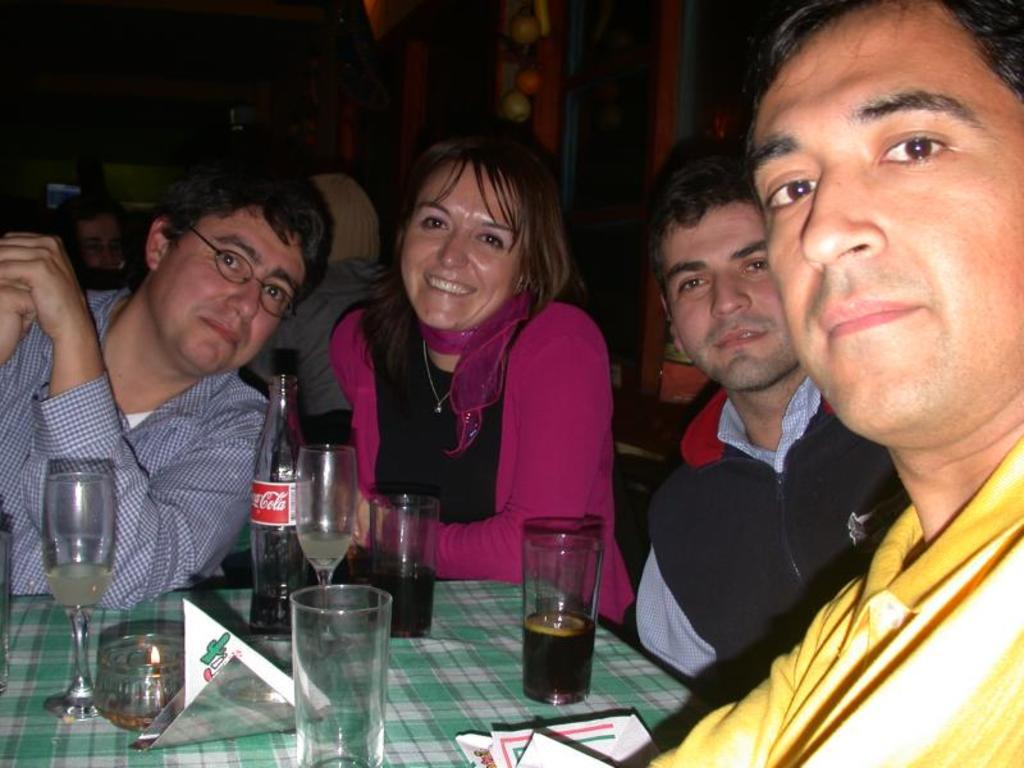Who or what can be seen in the image? There are people in the image. What are the people doing in the image? The people are sitting on chairs. Where is the faucet located in the image? There is no faucet present in the image. What type of brush can be seen in the hands of the people in the image? There is no brush visible in the hands of the people in the image. 